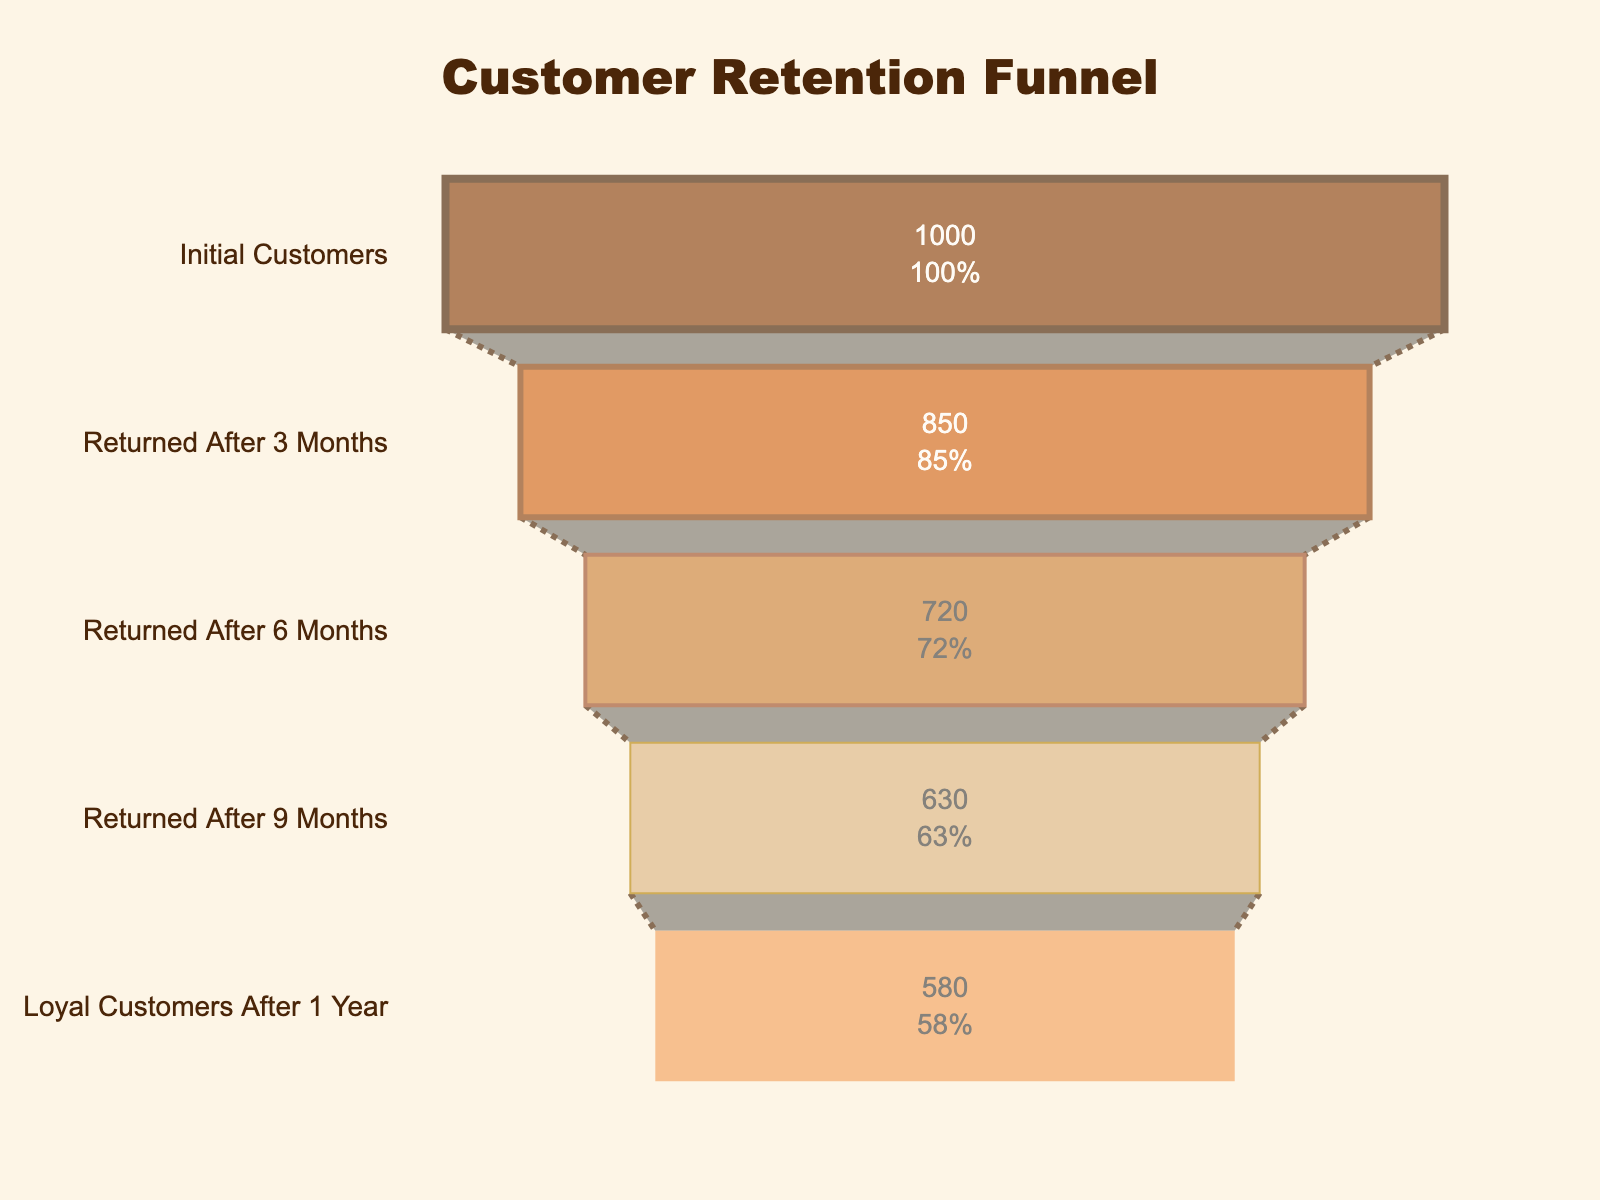What is the title of the funnel chart? The title is displayed prominently at the top of the chart, written in a larger and bold font.
Answer: Customer Retention Funnel How many stages are there in this funnel chart? The funnel chart consists of distinct horizontal segments, each representing a stage in the customer retention process. By counting these segments, we can determine the number of stages.
Answer: 5 What color is used for the "Returned After 6 Months" stage? The colors of each stage are evident from the visual representation in the chart. By identifying the segment corresponding to "Returned After 6 Months," we can match it to its color.
Answer: Light brown (#CD853F) What percentage of initial customers returned after 3 months? Funnel charts often include percentage values inside each stage. By locating the "Returned After 3 Months" stage and reading the percentage displayed, we get the answer.
Answer: 85% What is the difference in the number of customers between the "Returned After 6 Months" stage and the "Loyal Customers After 1 Year" stage? First, identify the customer counts for both stages: "Returned After 6 Months" has 720 customers, and "Loyal Customers After 1 Year" has 580 customers. Subtract the latter from the former to get the difference (720 - 580).
Answer: 140 What is the average number of customers retained across all stages? To find the average, sum the customer counts across all stages (1000 + 850 + 720 + 630 + 580) and divide by the number of stages (5). The total is 3780, and 3780/5 gives the average.
Answer: 756 Which stage has the least number of customers? By examining the values in each segment, we can identify the stage with the smallest number. The "Loyal Customers After 1 Year" stage has the fewest at 580 customers.
Answer: Loyal Customers After 1 Year What's the difference in customer retention between the initial stage and the last stage, expressed as a percentage? First, find the numbers of customers: initial (1000) and last (580). Calculate the percentage difference using the formula: ((initial - last)/initial) * 100. Which gives ((1000 - 580)/1000) * 100 = 42%.
Answer: 42% How many customers were lost between the "Returned After 3 Months" and "Loyal Customers After 1 Year" stages? Identify the number of customers at each stage: "Returned After 3 Months" (850) and "Loyal Customers After 1 Year" (580). Subtract to find the lost customers (850 - 580).
Answer: 270 